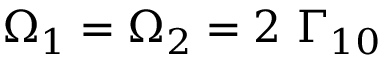Convert formula to latex. <formula><loc_0><loc_0><loc_500><loc_500>\Omega _ { 1 } = \Omega _ { 2 } = 2 \ \Gamma _ { 1 0 }</formula> 